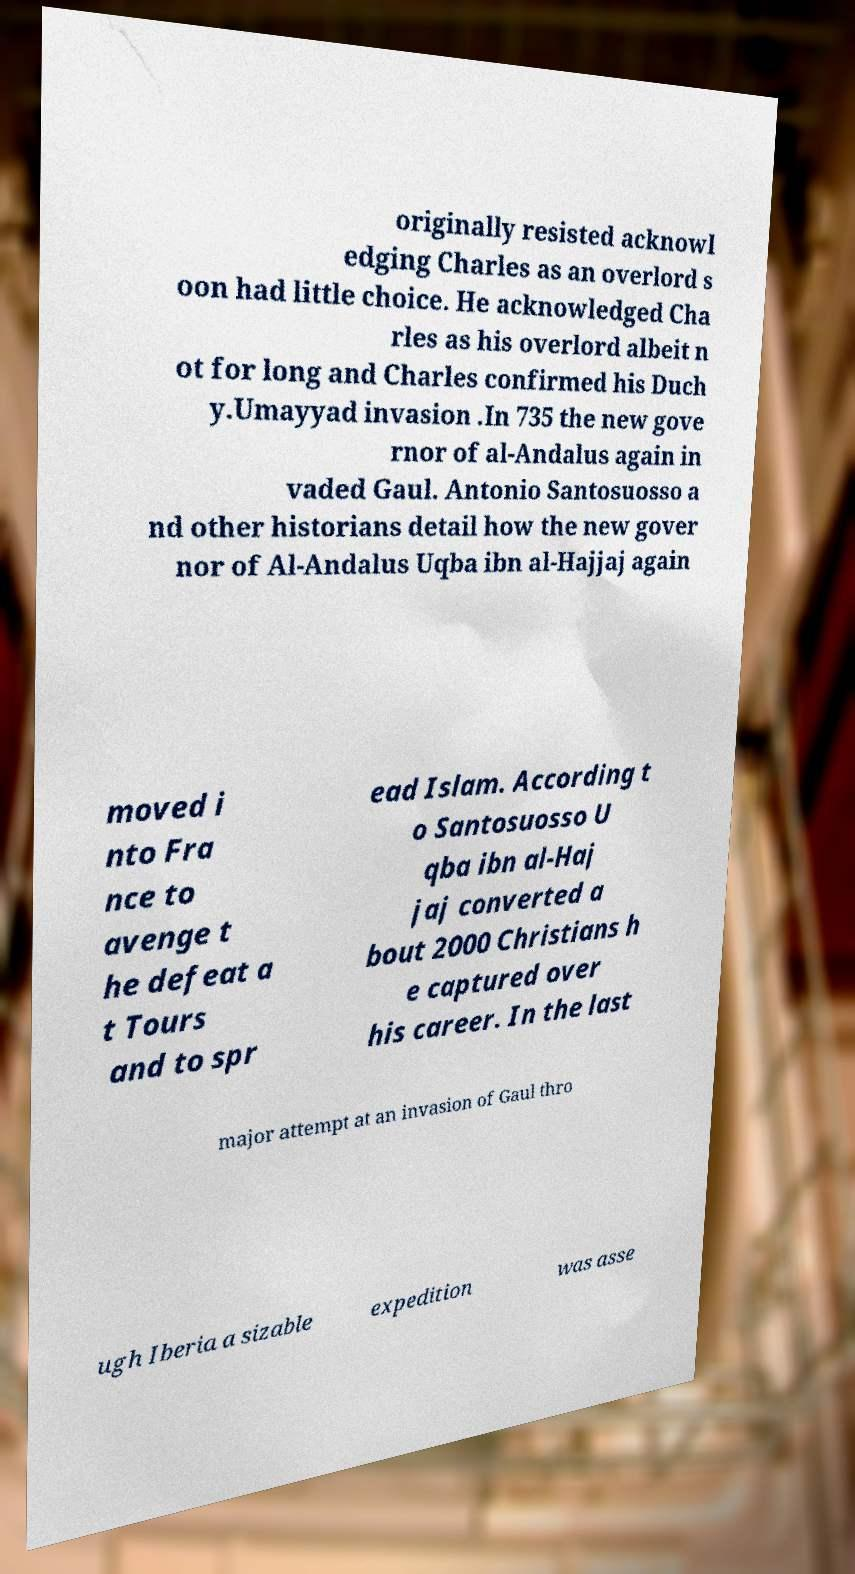Could you extract and type out the text from this image? originally resisted acknowl edging Charles as an overlord s oon had little choice. He acknowledged Cha rles as his overlord albeit n ot for long and Charles confirmed his Duch y.Umayyad invasion .In 735 the new gove rnor of al-Andalus again in vaded Gaul. Antonio Santosuosso a nd other historians detail how the new gover nor of Al-Andalus Uqba ibn al-Hajjaj again moved i nto Fra nce to avenge t he defeat a t Tours and to spr ead Islam. According t o Santosuosso U qba ibn al-Haj jaj converted a bout 2000 Christians h e captured over his career. In the last major attempt at an invasion of Gaul thro ugh Iberia a sizable expedition was asse 